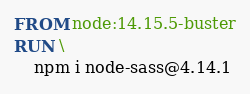<code> <loc_0><loc_0><loc_500><loc_500><_Dockerfile_>FROM node:14.15.5-buster
RUN \
    npm i node-sass@4.14.1</code> 